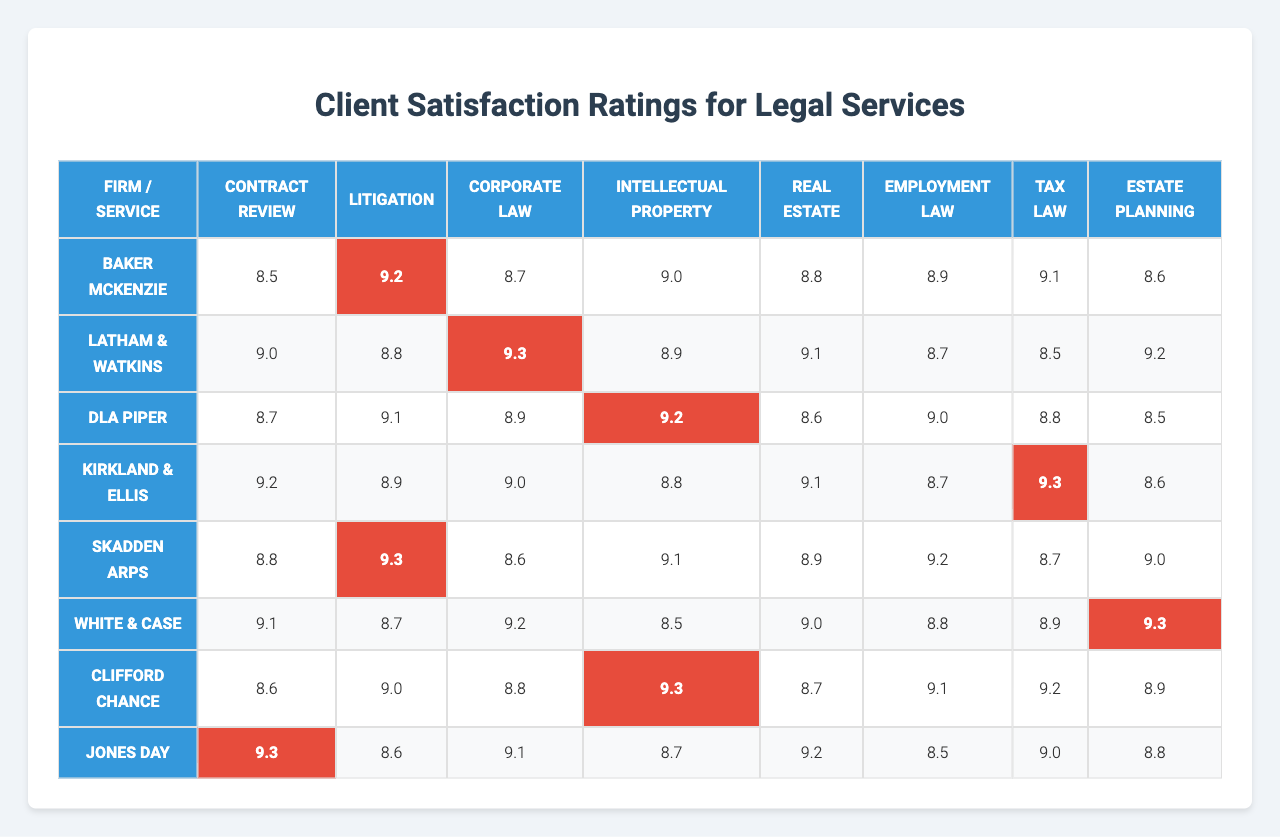What is the satisfaction rating for Baker McKenzie in Contract Review? The table lists the satisfaction ratings for each firm and service. Baker McKenzie has a rating of 8.5 for Contract Review.
Answer: 8.5 Which firm has the highest satisfaction rating for Litigation? The table displays the ratings, and the highest rating for Litigation is 9.3, which is given to both DLA Piper and Kirkland & Ellis.
Answer: DLA Piper and Kirkland & Ellis What is the average satisfaction rating for White & Case across all services? To find the average for White & Case, add all their ratings: (9.1 + 8.7 + 9.2 + 8.5 + 9.0 + 8.8 + 8.9 + 9.3) = 72.5. Then divide by the number of services (8): 72.5 / 8 = 9.0625.
Answer: 9.06 True or False: Skadden Arps has a satisfaction rating of 9.2 in Employment Law. By checking the table, Skadden Arps has a satisfaction rating of 8.8 in Employment Law, so the statement is false.
Answer: False Which service has the overall highest satisfaction rating across all firms? To determine this, compare ratings across all firms for each service. The service with the highest rating is Litigation with 9.3 (DLA Piper and Kirkland & Ellis).
Answer: Litigation What is the difference in satisfaction ratings between the highest and lowest rated firms for Estate Planning? For Estate Planning, Baker McKenzie has the lowest rating at 8.5, and DLA Piper has the highest rating at 9.2. The difference is 9.2 - 8.5 = 0.7.
Answer: 0.7 How many firms have a satisfaction rating above 9.0 in Tax Law? The Tax Law ratings are: Baker McKenzie (8.9), Latham & Watkins (9.0), DLA Piper (8.8), Kirkland & Ellis (9.1), Skadden Arps (9.2), White & Case (8.9), Clifford Chance (9.1), and Jones Day (9.0). The firms with ratings above 9.0 are Skadden Arps (9.2) and Clifford Chance (9.1), giving us a total of 3 firms.
Answer: 3 Which firm has the lowest satisfaction rating for Real Estate and what is that rating? Checking the ratings for Real Estate shows Baker McKenzie has the lowest rating at 8.8.
Answer: Baker McKenzie, 8.8 If we considered only the ratings of Corporate Law, what would be the second highest rating and which firm has it? The ratings for Corporate Law are: Baker McKenzie (8.9), Latham & Watkins (9.3), DLA Piper (9.0), Kirkland & Ellis (8.8), Skadden Arps (8.9), White & Case (9.0), Clifford Chance (9.1), Jones Day (9.1). The second highest rating is 9.1, shared by Clifford Chance and Jones Day.
Answer: 9.1, Clifford Chance and Jones Day 